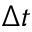<formula> <loc_0><loc_0><loc_500><loc_500>\Delta t</formula> 